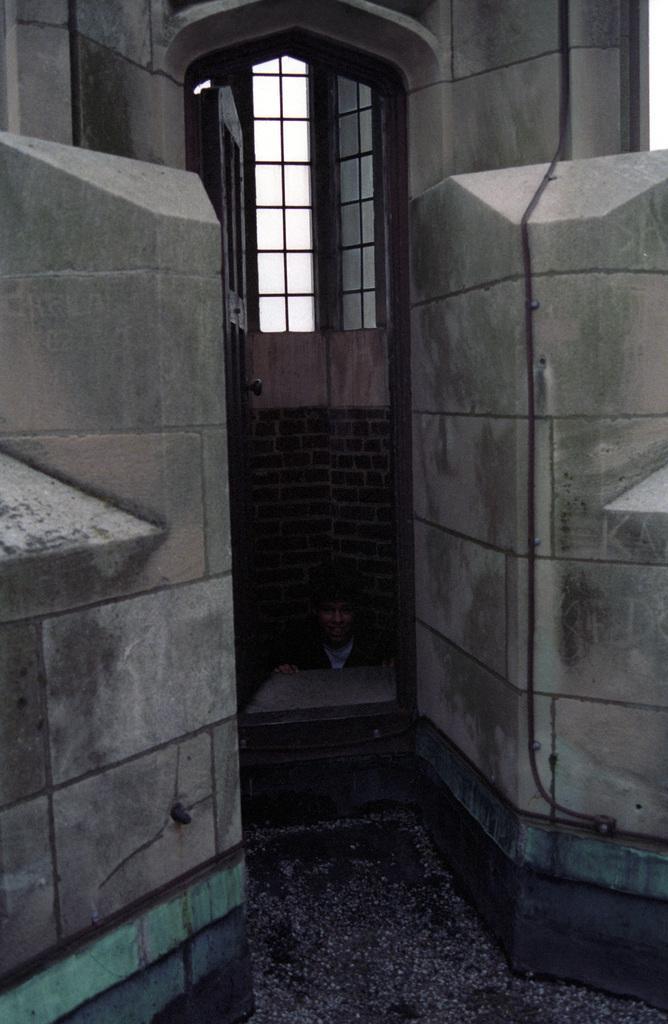Please provide a concise description of this image. In this picture we can see a man wearing helmet, door and window made of glass and walls and a pipeline along with that wall. 